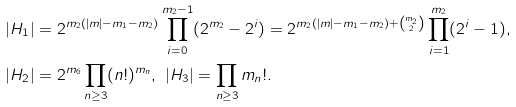Convert formula to latex. <formula><loc_0><loc_0><loc_500><loc_500>| H _ { 1 } | & = 2 ^ { m _ { 2 } ( | m | - m _ { 1 } - m _ { 2 } ) } \prod _ { i = 0 } ^ { m _ { 2 } - 1 } ( 2 ^ { m _ { 2 } } - 2 ^ { i } ) = 2 ^ { m _ { 2 } ( | m | - m _ { 1 } - m _ { 2 } ) + \binom { m _ { 2 } } { 2 } } \prod _ { i = 1 } ^ { m _ { 2 } } ( 2 ^ { i } - 1 ) , \\ | H _ { 2 } | & = 2 ^ { m _ { 6 } } \prod _ { n \geq 3 } ( n ! ) ^ { m _ { n } } , \ | H _ { 3 } | = \prod _ { n \geq 3 } m _ { n } ! .</formula> 